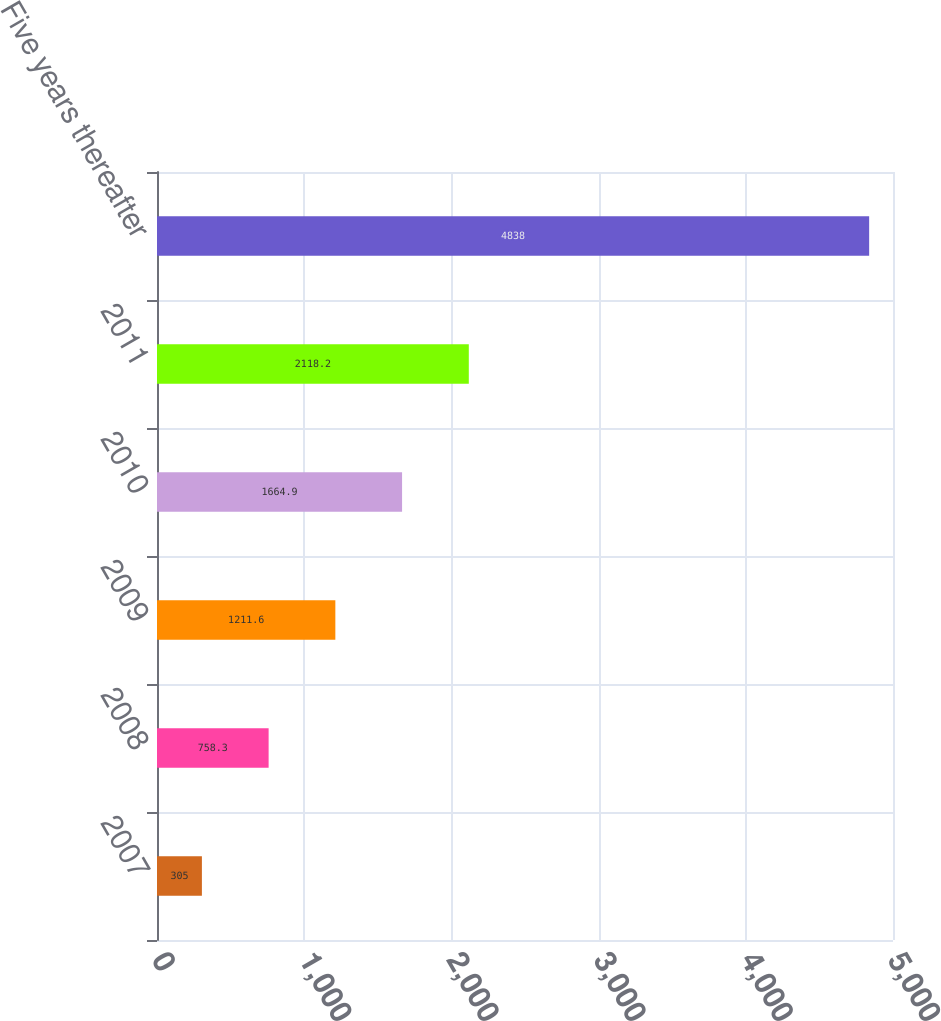Convert chart. <chart><loc_0><loc_0><loc_500><loc_500><bar_chart><fcel>2007<fcel>2008<fcel>2009<fcel>2010<fcel>2011<fcel>Five years thereafter<nl><fcel>305<fcel>758.3<fcel>1211.6<fcel>1664.9<fcel>2118.2<fcel>4838<nl></chart> 